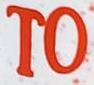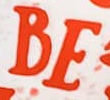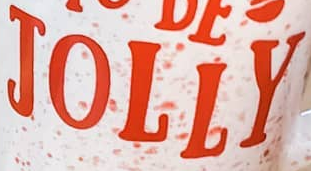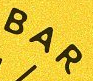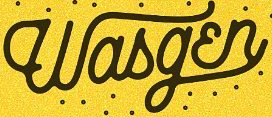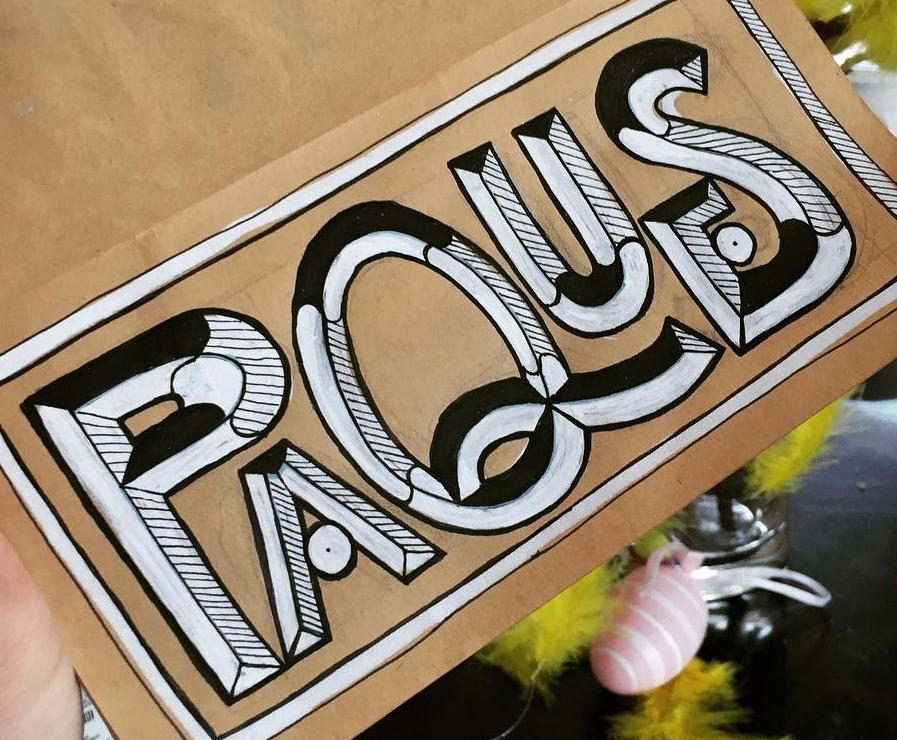Identify the words shown in these images in order, separated by a semicolon. TO; BE; JOLLY; BAR; Wasgɛn; PAQUES 